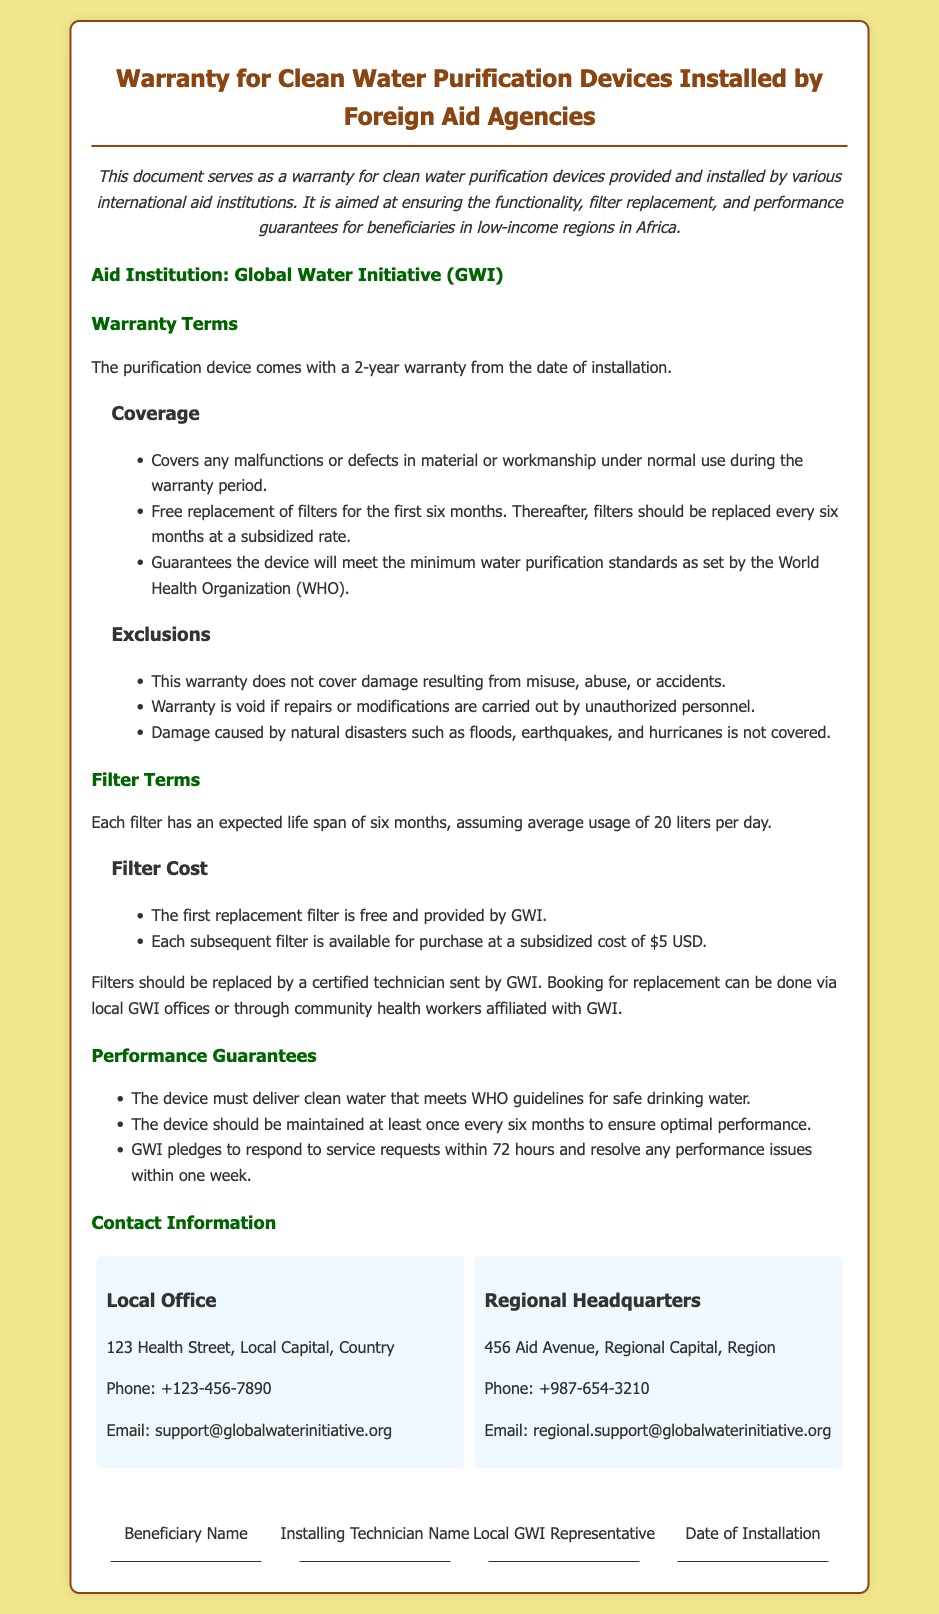What is the warranty period for the purification device? The warranty period is clearly stated in the document as lasting for 2 years from the date of installation.
Answer: 2 years Who provides the filters during the first six months? The warranty specifies that the first replacement filter is free and is provided by GWI.
Answer: GWI How often should the filters be replaced? The document mentions that filters should be replaced every six months assuming average usage.
Answer: every six months What is the subsidy cost for each subsequent filter? The document provides a price for filter replacements and specifies that each subsequent filter is available at a subsidized cost.
Answer: $5 USD What should be done if the purification device experiences performance issues? The document states that GWI pledges to respond to service requests within a specific timeframe for performance issues.
Answer: within 72 hours Who is responsible for filter replacement? The warranty states that filters should be replaced by a certified technician sent by GWI, giving clear responsibility for maintenance.
Answer: certified technician Which international organization’s guidelines must the device meet? The warranty specifies that the device is required to meet the minimum water purification standards as established by a specific organization.
Answer: World Health Organization (WHO) What type of damage is not covered by the warranty? The warranty explicitly lists the types of damage that are exclusions, including misuse, natural disasters, and unauthorized repairs.
Answer: misuse, natural disasters How many liters of water does the lifespan of a filter assume for correct usage? The document notes an average daily usage to determine the expected lifespan of the filter, highlighting a specific quantity.
Answer: 20 liters per day 